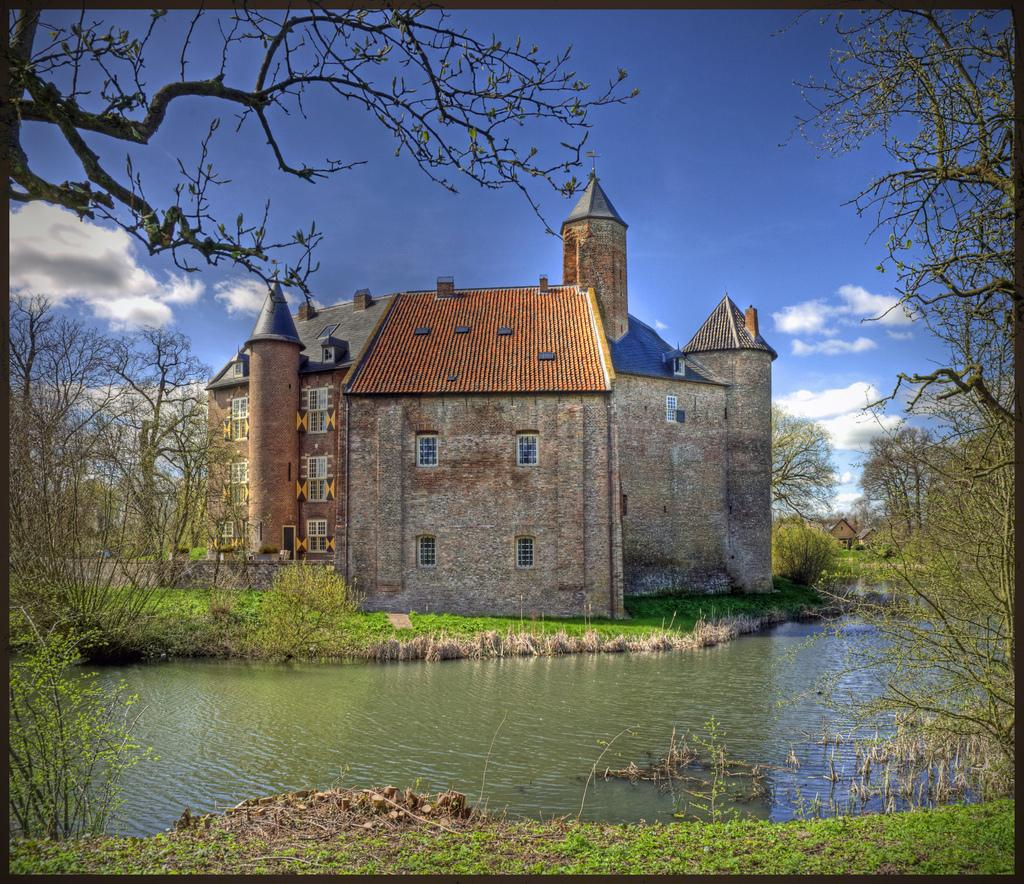What type of structure is present in the image? There is a building in the image. What natural element is visible in the image? There is a water surface visible in the image. What type of vegetation can be seen in the image? There are trees in the image. What can be seen in the sky in the background of the image? There are clouds in the sky in the background of the image. How many records can be seen floating on the water surface in the image? There are no records present in the image; it features a building, water surface, trees, and clouds in the sky. 